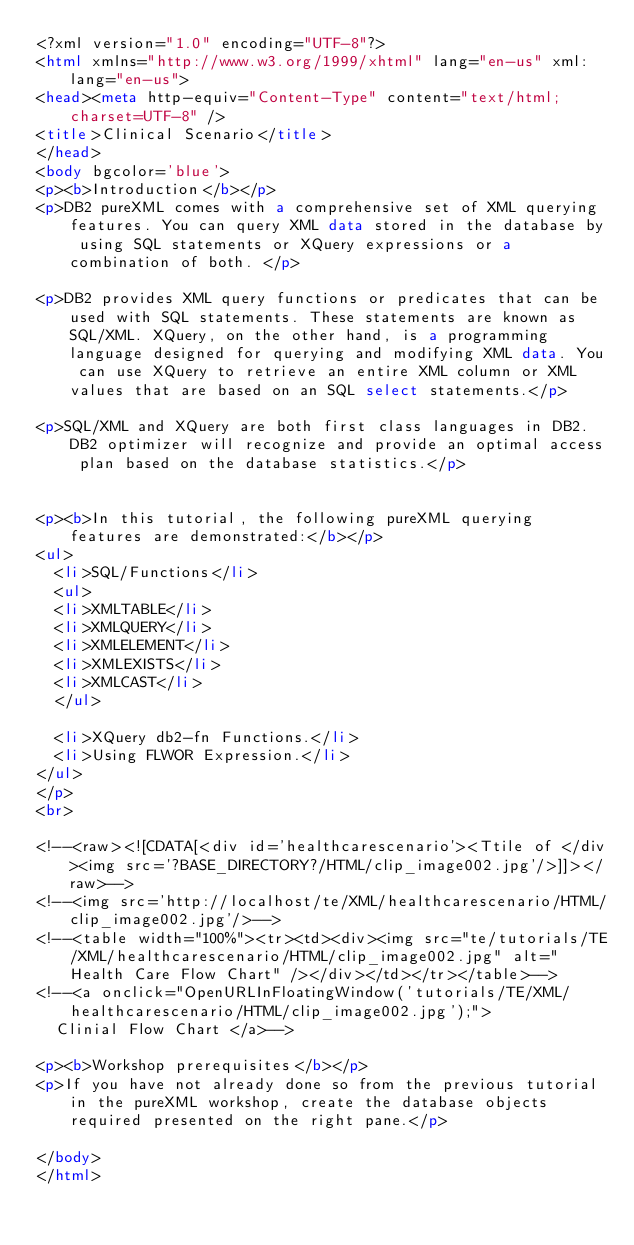<code> <loc_0><loc_0><loc_500><loc_500><_HTML_><?xml version="1.0" encoding="UTF-8"?>
<html xmlns="http://www.w3.org/1999/xhtml" lang="en-us" xml:lang="en-us">
<head><meta http-equiv="Content-Type" content="text/html; charset=UTF-8" />
<title>Clinical Scenario</title>
</head>
<body bgcolor='blue'>
<p><b>Introduction</b></p>
<p>DB2 pureXML comes with a comprehensive set of XML querying features. You can query XML data stored in the database by using SQL statements or XQuery expressions or a combination of both. </p>

<p>DB2 provides XML query functions or predicates that can be used with SQL statements. These statements are known as SQL/XML. XQuery, on the other hand, is a programming language designed for querying and modifying XML data. You can use XQuery to retrieve an entire XML column or XML values that are based on an SQL select statements.</p>

<p>SQL/XML and XQuery are both first class languages in DB2. DB2 optimizer will recognize and provide an optimal access plan based on the database statistics.</p>


<p><b>In this tutorial, the following pureXML querying features are demonstrated:</b></p>
<ul>
	<li>SQL/Functions</li>
	<ul>
	<li>XMLTABLE</li>
	<li>XMLQUERY</li>
	<li>XMLELEMENT</li>
	<li>XMLEXISTS</li>
	<li>XMLCAST</li>
	</ul>

	<li>XQuery db2-fn Functions.</li>
	<li>Using FLWOR Expression.</li>
</ul>
</p>
<br>

<!--<raw><![CDATA[<div id='healthcarescenario'><Ttile of </div><img src='?BASE_DIRECTORY?/HTML/clip_image002.jpg'/>]]></raw>-->
<!--<img src='http://localhost/te/XML/healthcarescenario/HTML/clip_image002.jpg'/>-->
<!--<table width="100%"><tr><td><div><img src="te/tutorials/TE/XML/healthcarescenario/HTML/clip_image002.jpg" alt="Health Care Flow Chart" /></div></td></tr></table>-->
<!--<a onclick="OpenURLInFloatingWindow('tutorials/TE/XML/healthcarescenario/HTML/clip_image002.jpg');">
	Clinial Flow Chart </a>-->

<p><b>Workshop prerequisites</b></p>
<p>If you have not already done so from the previous tutorial in the pureXML workshop, create the database objects required presented on the right pane.</p>

</body>
</html></code> 